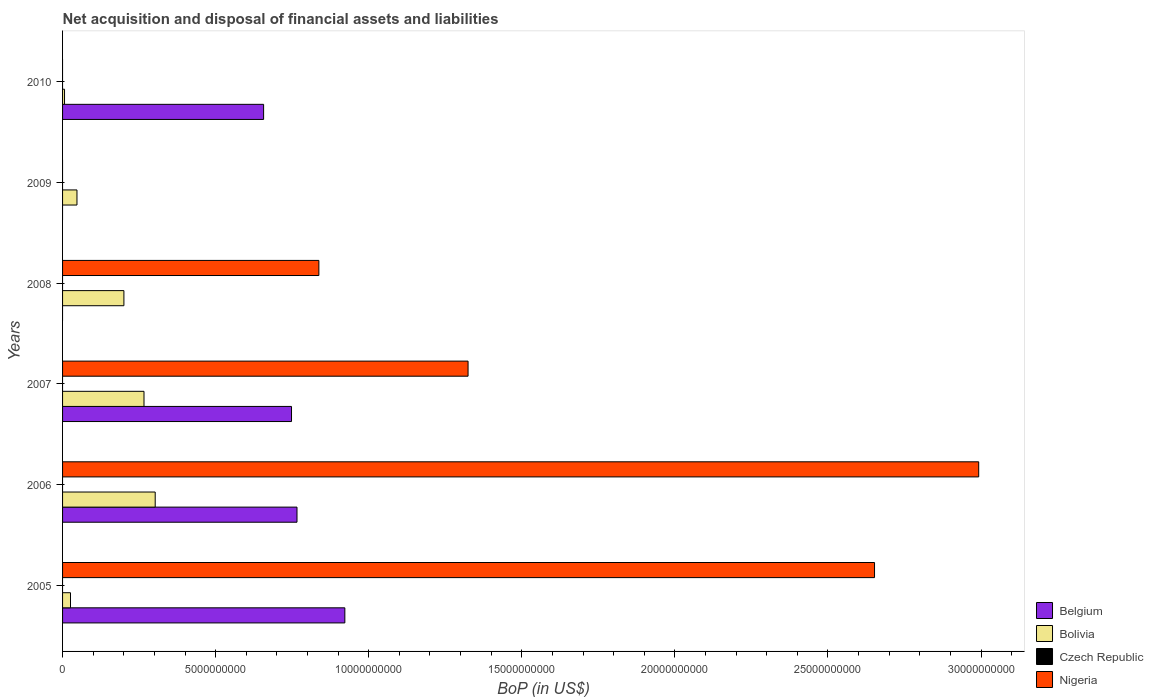Are the number of bars on each tick of the Y-axis equal?
Keep it short and to the point. No. How many bars are there on the 5th tick from the top?
Provide a short and direct response. 3. How many bars are there on the 6th tick from the bottom?
Give a very brief answer. 2. In how many cases, is the number of bars for a given year not equal to the number of legend labels?
Offer a terse response. 6. What is the Balance of Payments in Nigeria in 2007?
Offer a very short reply. 1.32e+1. Across all years, what is the maximum Balance of Payments in Belgium?
Keep it short and to the point. 9.22e+09. Across all years, what is the minimum Balance of Payments in Belgium?
Offer a terse response. 0. In which year was the Balance of Payments in Nigeria maximum?
Provide a succinct answer. 2006. What is the total Balance of Payments in Nigeria in the graph?
Offer a very short reply. 7.81e+1. What is the difference between the Balance of Payments in Bolivia in 2006 and that in 2010?
Provide a short and direct response. 2.96e+09. What is the difference between the Balance of Payments in Nigeria in 2006 and the Balance of Payments in Czech Republic in 2007?
Give a very brief answer. 2.99e+1. What is the average Balance of Payments in Bolivia per year?
Make the answer very short. 1.41e+09. In the year 2005, what is the difference between the Balance of Payments in Nigeria and Balance of Payments in Belgium?
Your response must be concise. 1.73e+1. In how many years, is the Balance of Payments in Bolivia greater than 19000000000 US$?
Keep it short and to the point. 0. What is the ratio of the Balance of Payments in Bolivia in 2009 to that in 2010?
Your answer should be very brief. 7.32. What is the difference between the highest and the second highest Balance of Payments in Bolivia?
Your answer should be compact. 3.66e+08. What is the difference between the highest and the lowest Balance of Payments in Nigeria?
Your response must be concise. 2.99e+1. Is the sum of the Balance of Payments in Belgium in 2006 and 2007 greater than the maximum Balance of Payments in Nigeria across all years?
Keep it short and to the point. No. Is it the case that in every year, the sum of the Balance of Payments in Bolivia and Balance of Payments in Belgium is greater than the sum of Balance of Payments in Nigeria and Balance of Payments in Czech Republic?
Your response must be concise. No. Is it the case that in every year, the sum of the Balance of Payments in Belgium and Balance of Payments in Czech Republic is greater than the Balance of Payments in Nigeria?
Ensure brevity in your answer.  No. How many bars are there?
Provide a short and direct response. 14. What is the difference between two consecutive major ticks on the X-axis?
Offer a terse response. 5.00e+09. Are the values on the major ticks of X-axis written in scientific E-notation?
Offer a terse response. No. Does the graph contain grids?
Ensure brevity in your answer.  No. Where does the legend appear in the graph?
Ensure brevity in your answer.  Bottom right. How many legend labels are there?
Make the answer very short. 4. What is the title of the graph?
Make the answer very short. Net acquisition and disposal of financial assets and liabilities. Does "Antigua and Barbuda" appear as one of the legend labels in the graph?
Give a very brief answer. No. What is the label or title of the X-axis?
Make the answer very short. BoP (in US$). What is the BoP (in US$) of Belgium in 2005?
Provide a short and direct response. 9.22e+09. What is the BoP (in US$) in Bolivia in 2005?
Provide a succinct answer. 2.59e+08. What is the BoP (in US$) in Czech Republic in 2005?
Provide a succinct answer. 0. What is the BoP (in US$) of Nigeria in 2005?
Your answer should be very brief. 2.65e+1. What is the BoP (in US$) in Belgium in 2006?
Provide a succinct answer. 7.66e+09. What is the BoP (in US$) of Bolivia in 2006?
Offer a terse response. 3.03e+09. What is the BoP (in US$) of Nigeria in 2006?
Your answer should be very brief. 2.99e+1. What is the BoP (in US$) of Belgium in 2007?
Ensure brevity in your answer.  7.48e+09. What is the BoP (in US$) in Bolivia in 2007?
Provide a succinct answer. 2.66e+09. What is the BoP (in US$) of Czech Republic in 2007?
Your response must be concise. 0. What is the BoP (in US$) of Nigeria in 2007?
Provide a short and direct response. 1.32e+1. What is the BoP (in US$) in Bolivia in 2008?
Make the answer very short. 2.00e+09. What is the BoP (in US$) in Nigeria in 2008?
Give a very brief answer. 8.37e+09. What is the BoP (in US$) in Belgium in 2009?
Give a very brief answer. 0. What is the BoP (in US$) in Bolivia in 2009?
Provide a short and direct response. 4.71e+08. What is the BoP (in US$) in Belgium in 2010?
Keep it short and to the point. 6.57e+09. What is the BoP (in US$) of Bolivia in 2010?
Ensure brevity in your answer.  6.43e+07. What is the BoP (in US$) of Nigeria in 2010?
Ensure brevity in your answer.  0. Across all years, what is the maximum BoP (in US$) in Belgium?
Offer a very short reply. 9.22e+09. Across all years, what is the maximum BoP (in US$) of Bolivia?
Your answer should be compact. 3.03e+09. Across all years, what is the maximum BoP (in US$) of Nigeria?
Give a very brief answer. 2.99e+1. Across all years, what is the minimum BoP (in US$) of Belgium?
Provide a succinct answer. 0. Across all years, what is the minimum BoP (in US$) in Bolivia?
Provide a succinct answer. 6.43e+07. What is the total BoP (in US$) of Belgium in the graph?
Your response must be concise. 3.09e+1. What is the total BoP (in US$) in Bolivia in the graph?
Ensure brevity in your answer.  8.48e+09. What is the total BoP (in US$) in Nigeria in the graph?
Give a very brief answer. 7.81e+1. What is the difference between the BoP (in US$) in Belgium in 2005 and that in 2006?
Provide a succinct answer. 1.56e+09. What is the difference between the BoP (in US$) of Bolivia in 2005 and that in 2006?
Your answer should be compact. -2.77e+09. What is the difference between the BoP (in US$) in Nigeria in 2005 and that in 2006?
Your answer should be compact. -3.40e+09. What is the difference between the BoP (in US$) in Belgium in 2005 and that in 2007?
Keep it short and to the point. 1.74e+09. What is the difference between the BoP (in US$) in Bolivia in 2005 and that in 2007?
Ensure brevity in your answer.  -2.40e+09. What is the difference between the BoP (in US$) of Nigeria in 2005 and that in 2007?
Offer a very short reply. 1.33e+1. What is the difference between the BoP (in US$) in Bolivia in 2005 and that in 2008?
Your answer should be compact. -1.74e+09. What is the difference between the BoP (in US$) in Nigeria in 2005 and that in 2008?
Your answer should be very brief. 1.81e+1. What is the difference between the BoP (in US$) of Bolivia in 2005 and that in 2009?
Your response must be concise. -2.11e+08. What is the difference between the BoP (in US$) of Belgium in 2005 and that in 2010?
Offer a very short reply. 2.65e+09. What is the difference between the BoP (in US$) in Bolivia in 2005 and that in 2010?
Offer a very short reply. 1.95e+08. What is the difference between the BoP (in US$) of Belgium in 2006 and that in 2007?
Offer a very short reply. 1.79e+08. What is the difference between the BoP (in US$) of Bolivia in 2006 and that in 2007?
Offer a very short reply. 3.66e+08. What is the difference between the BoP (in US$) in Nigeria in 2006 and that in 2007?
Ensure brevity in your answer.  1.67e+1. What is the difference between the BoP (in US$) of Bolivia in 2006 and that in 2008?
Provide a succinct answer. 1.02e+09. What is the difference between the BoP (in US$) in Nigeria in 2006 and that in 2008?
Provide a succinct answer. 2.16e+1. What is the difference between the BoP (in US$) in Bolivia in 2006 and that in 2009?
Give a very brief answer. 2.56e+09. What is the difference between the BoP (in US$) of Belgium in 2006 and that in 2010?
Provide a succinct answer. 1.09e+09. What is the difference between the BoP (in US$) of Bolivia in 2006 and that in 2010?
Provide a succinct answer. 2.96e+09. What is the difference between the BoP (in US$) of Bolivia in 2007 and that in 2008?
Provide a succinct answer. 6.56e+08. What is the difference between the BoP (in US$) in Nigeria in 2007 and that in 2008?
Your answer should be compact. 4.87e+09. What is the difference between the BoP (in US$) in Bolivia in 2007 and that in 2009?
Your answer should be very brief. 2.19e+09. What is the difference between the BoP (in US$) of Belgium in 2007 and that in 2010?
Make the answer very short. 9.11e+08. What is the difference between the BoP (in US$) in Bolivia in 2007 and that in 2010?
Provide a succinct answer. 2.60e+09. What is the difference between the BoP (in US$) of Bolivia in 2008 and that in 2009?
Keep it short and to the point. 1.53e+09. What is the difference between the BoP (in US$) of Bolivia in 2008 and that in 2010?
Provide a succinct answer. 1.94e+09. What is the difference between the BoP (in US$) of Bolivia in 2009 and that in 2010?
Your answer should be very brief. 4.06e+08. What is the difference between the BoP (in US$) of Belgium in 2005 and the BoP (in US$) of Bolivia in 2006?
Ensure brevity in your answer.  6.19e+09. What is the difference between the BoP (in US$) of Belgium in 2005 and the BoP (in US$) of Nigeria in 2006?
Offer a very short reply. -2.07e+1. What is the difference between the BoP (in US$) in Bolivia in 2005 and the BoP (in US$) in Nigeria in 2006?
Give a very brief answer. -2.97e+1. What is the difference between the BoP (in US$) in Belgium in 2005 and the BoP (in US$) in Bolivia in 2007?
Give a very brief answer. 6.56e+09. What is the difference between the BoP (in US$) of Belgium in 2005 and the BoP (in US$) of Nigeria in 2007?
Make the answer very short. -4.02e+09. What is the difference between the BoP (in US$) of Bolivia in 2005 and the BoP (in US$) of Nigeria in 2007?
Your response must be concise. -1.30e+1. What is the difference between the BoP (in US$) of Belgium in 2005 and the BoP (in US$) of Bolivia in 2008?
Provide a short and direct response. 7.22e+09. What is the difference between the BoP (in US$) in Belgium in 2005 and the BoP (in US$) in Nigeria in 2008?
Ensure brevity in your answer.  8.48e+08. What is the difference between the BoP (in US$) of Bolivia in 2005 and the BoP (in US$) of Nigeria in 2008?
Your response must be concise. -8.11e+09. What is the difference between the BoP (in US$) in Belgium in 2005 and the BoP (in US$) in Bolivia in 2009?
Keep it short and to the point. 8.75e+09. What is the difference between the BoP (in US$) of Belgium in 2005 and the BoP (in US$) of Bolivia in 2010?
Your response must be concise. 9.16e+09. What is the difference between the BoP (in US$) in Belgium in 2006 and the BoP (in US$) in Bolivia in 2007?
Provide a succinct answer. 5.00e+09. What is the difference between the BoP (in US$) of Belgium in 2006 and the BoP (in US$) of Nigeria in 2007?
Provide a short and direct response. -5.59e+09. What is the difference between the BoP (in US$) of Bolivia in 2006 and the BoP (in US$) of Nigeria in 2007?
Your answer should be compact. -1.02e+1. What is the difference between the BoP (in US$) in Belgium in 2006 and the BoP (in US$) in Bolivia in 2008?
Keep it short and to the point. 5.65e+09. What is the difference between the BoP (in US$) in Belgium in 2006 and the BoP (in US$) in Nigeria in 2008?
Your answer should be compact. -7.15e+08. What is the difference between the BoP (in US$) in Bolivia in 2006 and the BoP (in US$) in Nigeria in 2008?
Give a very brief answer. -5.35e+09. What is the difference between the BoP (in US$) of Belgium in 2006 and the BoP (in US$) of Bolivia in 2009?
Ensure brevity in your answer.  7.19e+09. What is the difference between the BoP (in US$) of Belgium in 2006 and the BoP (in US$) of Bolivia in 2010?
Offer a terse response. 7.59e+09. What is the difference between the BoP (in US$) of Belgium in 2007 and the BoP (in US$) of Bolivia in 2008?
Keep it short and to the point. 5.47e+09. What is the difference between the BoP (in US$) in Belgium in 2007 and the BoP (in US$) in Nigeria in 2008?
Your response must be concise. -8.94e+08. What is the difference between the BoP (in US$) of Bolivia in 2007 and the BoP (in US$) of Nigeria in 2008?
Keep it short and to the point. -5.71e+09. What is the difference between the BoP (in US$) in Belgium in 2007 and the BoP (in US$) in Bolivia in 2009?
Your response must be concise. 7.01e+09. What is the difference between the BoP (in US$) of Belgium in 2007 and the BoP (in US$) of Bolivia in 2010?
Provide a succinct answer. 7.41e+09. What is the average BoP (in US$) in Belgium per year?
Keep it short and to the point. 5.15e+09. What is the average BoP (in US$) in Bolivia per year?
Give a very brief answer. 1.41e+09. What is the average BoP (in US$) of Nigeria per year?
Your answer should be very brief. 1.30e+1. In the year 2005, what is the difference between the BoP (in US$) in Belgium and BoP (in US$) in Bolivia?
Provide a short and direct response. 8.96e+09. In the year 2005, what is the difference between the BoP (in US$) in Belgium and BoP (in US$) in Nigeria?
Offer a very short reply. -1.73e+1. In the year 2005, what is the difference between the BoP (in US$) in Bolivia and BoP (in US$) in Nigeria?
Your answer should be compact. -2.63e+1. In the year 2006, what is the difference between the BoP (in US$) of Belgium and BoP (in US$) of Bolivia?
Your answer should be compact. 4.63e+09. In the year 2006, what is the difference between the BoP (in US$) of Belgium and BoP (in US$) of Nigeria?
Keep it short and to the point. -2.23e+1. In the year 2006, what is the difference between the BoP (in US$) in Bolivia and BoP (in US$) in Nigeria?
Offer a very short reply. -2.69e+1. In the year 2007, what is the difference between the BoP (in US$) of Belgium and BoP (in US$) of Bolivia?
Give a very brief answer. 4.82e+09. In the year 2007, what is the difference between the BoP (in US$) in Belgium and BoP (in US$) in Nigeria?
Your answer should be very brief. -5.77e+09. In the year 2007, what is the difference between the BoP (in US$) in Bolivia and BoP (in US$) in Nigeria?
Provide a succinct answer. -1.06e+1. In the year 2008, what is the difference between the BoP (in US$) in Bolivia and BoP (in US$) in Nigeria?
Your answer should be very brief. -6.37e+09. In the year 2010, what is the difference between the BoP (in US$) in Belgium and BoP (in US$) in Bolivia?
Your response must be concise. 6.50e+09. What is the ratio of the BoP (in US$) in Belgium in 2005 to that in 2006?
Make the answer very short. 1.2. What is the ratio of the BoP (in US$) of Bolivia in 2005 to that in 2006?
Make the answer very short. 0.09. What is the ratio of the BoP (in US$) in Nigeria in 2005 to that in 2006?
Keep it short and to the point. 0.89. What is the ratio of the BoP (in US$) in Belgium in 2005 to that in 2007?
Make the answer very short. 1.23. What is the ratio of the BoP (in US$) of Bolivia in 2005 to that in 2007?
Your answer should be compact. 0.1. What is the ratio of the BoP (in US$) in Nigeria in 2005 to that in 2007?
Provide a succinct answer. 2. What is the ratio of the BoP (in US$) in Bolivia in 2005 to that in 2008?
Your answer should be compact. 0.13. What is the ratio of the BoP (in US$) of Nigeria in 2005 to that in 2008?
Offer a very short reply. 3.17. What is the ratio of the BoP (in US$) of Bolivia in 2005 to that in 2009?
Your answer should be very brief. 0.55. What is the ratio of the BoP (in US$) of Belgium in 2005 to that in 2010?
Make the answer very short. 1.4. What is the ratio of the BoP (in US$) of Bolivia in 2005 to that in 2010?
Give a very brief answer. 4.03. What is the ratio of the BoP (in US$) of Belgium in 2006 to that in 2007?
Keep it short and to the point. 1.02. What is the ratio of the BoP (in US$) of Bolivia in 2006 to that in 2007?
Offer a terse response. 1.14. What is the ratio of the BoP (in US$) in Nigeria in 2006 to that in 2007?
Give a very brief answer. 2.26. What is the ratio of the BoP (in US$) of Bolivia in 2006 to that in 2008?
Your answer should be very brief. 1.51. What is the ratio of the BoP (in US$) of Nigeria in 2006 to that in 2008?
Offer a very short reply. 3.57. What is the ratio of the BoP (in US$) in Bolivia in 2006 to that in 2009?
Provide a short and direct response. 6.43. What is the ratio of the BoP (in US$) of Belgium in 2006 to that in 2010?
Your answer should be very brief. 1.17. What is the ratio of the BoP (in US$) of Bolivia in 2006 to that in 2010?
Give a very brief answer. 47.07. What is the ratio of the BoP (in US$) in Bolivia in 2007 to that in 2008?
Offer a terse response. 1.33. What is the ratio of the BoP (in US$) in Nigeria in 2007 to that in 2008?
Make the answer very short. 1.58. What is the ratio of the BoP (in US$) in Bolivia in 2007 to that in 2009?
Your answer should be very brief. 5.65. What is the ratio of the BoP (in US$) in Belgium in 2007 to that in 2010?
Your answer should be very brief. 1.14. What is the ratio of the BoP (in US$) of Bolivia in 2007 to that in 2010?
Offer a very short reply. 41.38. What is the ratio of the BoP (in US$) in Bolivia in 2008 to that in 2009?
Keep it short and to the point. 4.26. What is the ratio of the BoP (in US$) in Bolivia in 2008 to that in 2010?
Ensure brevity in your answer.  31.17. What is the ratio of the BoP (in US$) of Bolivia in 2009 to that in 2010?
Your answer should be very brief. 7.32. What is the difference between the highest and the second highest BoP (in US$) of Belgium?
Provide a short and direct response. 1.56e+09. What is the difference between the highest and the second highest BoP (in US$) in Bolivia?
Offer a terse response. 3.66e+08. What is the difference between the highest and the second highest BoP (in US$) in Nigeria?
Offer a very short reply. 3.40e+09. What is the difference between the highest and the lowest BoP (in US$) in Belgium?
Ensure brevity in your answer.  9.22e+09. What is the difference between the highest and the lowest BoP (in US$) in Bolivia?
Provide a short and direct response. 2.96e+09. What is the difference between the highest and the lowest BoP (in US$) of Nigeria?
Ensure brevity in your answer.  2.99e+1. 